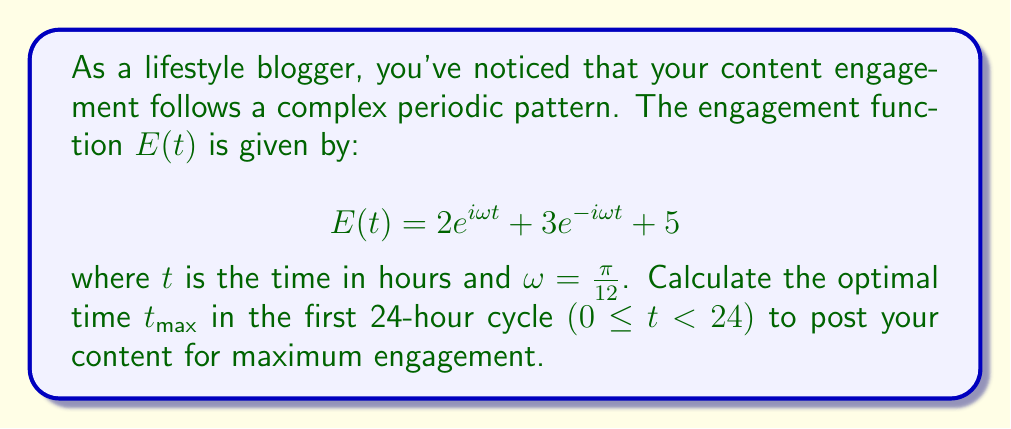Can you answer this question? To find the optimal time for maximum engagement, we need to find the maximum of the real part of $E(t)$. Let's approach this step-by-step:

1) First, let's simplify the complex exponential terms using Euler's formula:
   $e^{i\omega t} = \cos(\omega t) + i\sin(\omega t)$
   $e^{-i\omega t} = \cos(\omega t) - i\sin(\omega t)$

2) Substituting these into our function:
   $E(t) = 2(\cos(\omega t) + i\sin(\omega t)) + 3(\cos(\omega t) - i\sin(\omega t)) + 5$

3) Simplifying:
   $E(t) = (2+3)\cos(\omega t) + (2-3)i\sin(\omega t) + 5$
   $E(t) = 5\cos(\omega t) - i\sin(\omega t) + 5$

4) The real part of this function is what determines the engagement:
   $\text{Re}(E(t)) = 5\cos(\omega t) + 5$

5) To find the maximum, we need to find where the derivative of this function is zero:
   $\frac{d}{dt}\text{Re}(E(t)) = -5\omega\sin(\omega t) = 0$

6) This occurs when $\sin(\omega t) = 0$, which happens when $\omega t = 0, \pi, 2\pi, ...$

7) Solving for $t$:
   $t = 0, \frac{12}{\pi}\pi = 12, \frac{24}{\pi}\pi = 24, ...$

8) Within the first 24-hour cycle, the maximum occurs at $t = 0$ or $t = 24$ (which is equivalent to $t = 0$ in the next cycle).

9) To verify this is a maximum and not a minimum, we can check the second derivative:
   $\frac{d^2}{dt^2}\text{Re}(E(t)) = -5\omega^2\cos(\omega t)$
   At $t = 0$, this is negative, confirming a maximum.

Therefore, the optimal time to post for maximum engagement is at $t = 0$ hours, or midnight.
Answer: $t_{\text{max}} = 0$ hours 